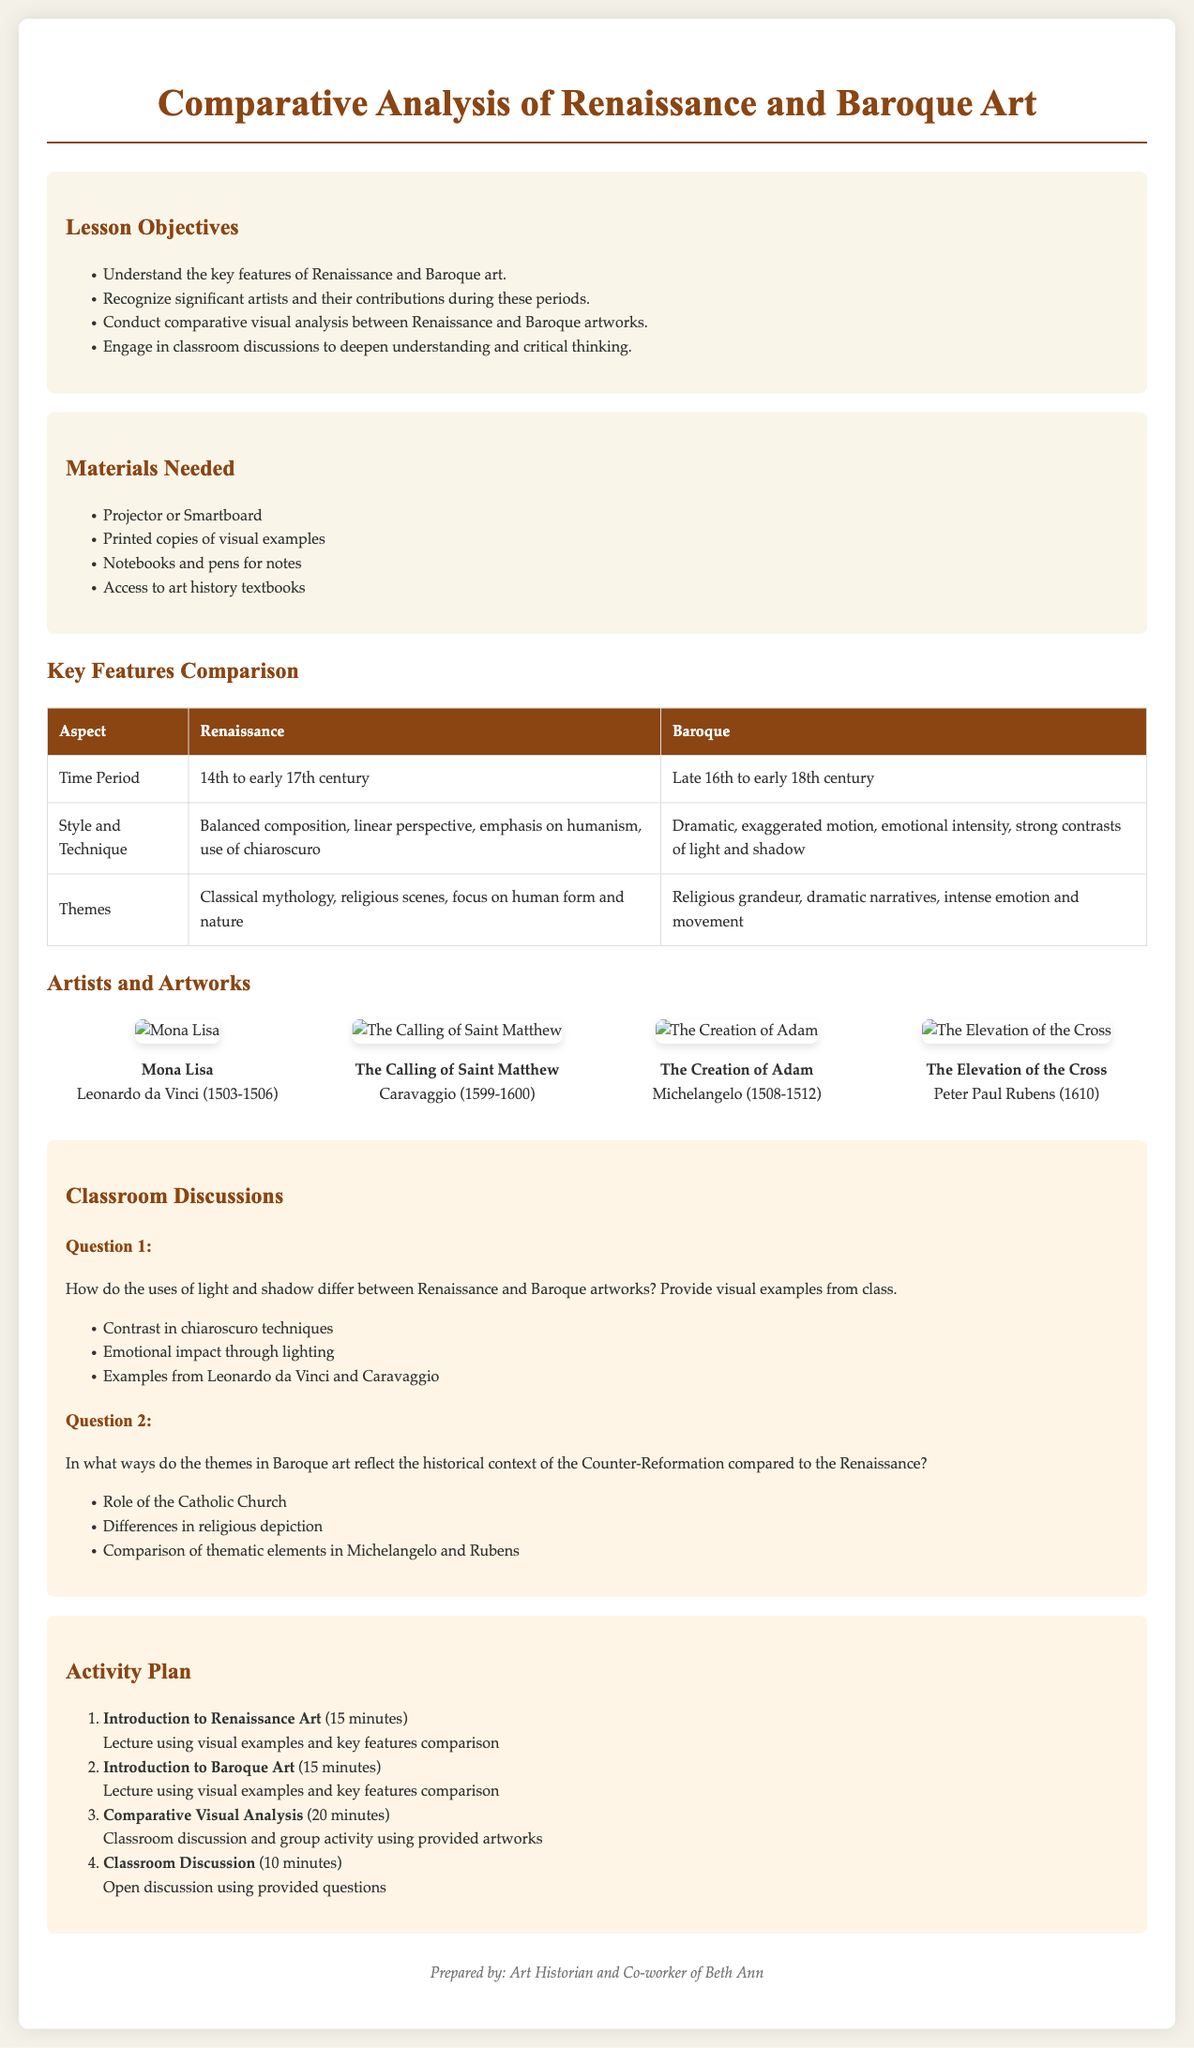What is the time period of the Renaissance? The time period of the Renaissance is from the 14th to early 17th century.
Answer: 14th to early 17th century Who created the artwork "Mona Lisa"? "Mona Lisa" was created by Leonardo da Vinci.
Answer: Leonardo da Vinci What is one key feature of Baroque art? One key feature of Baroque art is dramatic, exaggerated motion.
Answer: Dramatic, exaggerated motion Which two artists are compared in the second classroom discussion question? The artists compared in the second discussion question are Michelangelo and Rubens.
Answer: Michelangelo and Rubens How long is the introduction to Baroque art section? The introduction to Baroque art section is 15 minutes long.
Answer: 15 minutes What lighting technique is specifically mentioned in the first classroom discussion question? The lighting technique mentioned is chiaroscuro.
Answer: Chiaroscuro What is the total number of artworks displayed in the document? There are a total of 4 artworks displayed in the document.
Answer: 4 artworks What type of materials is required for the lesson? The materials required include printed copies of visual examples.
Answer: Printed copies of visual examples What is the primary focus of Renaissance themes? The primary focus of Renaissance themes is on human form and nature.
Answer: Human form and nature 